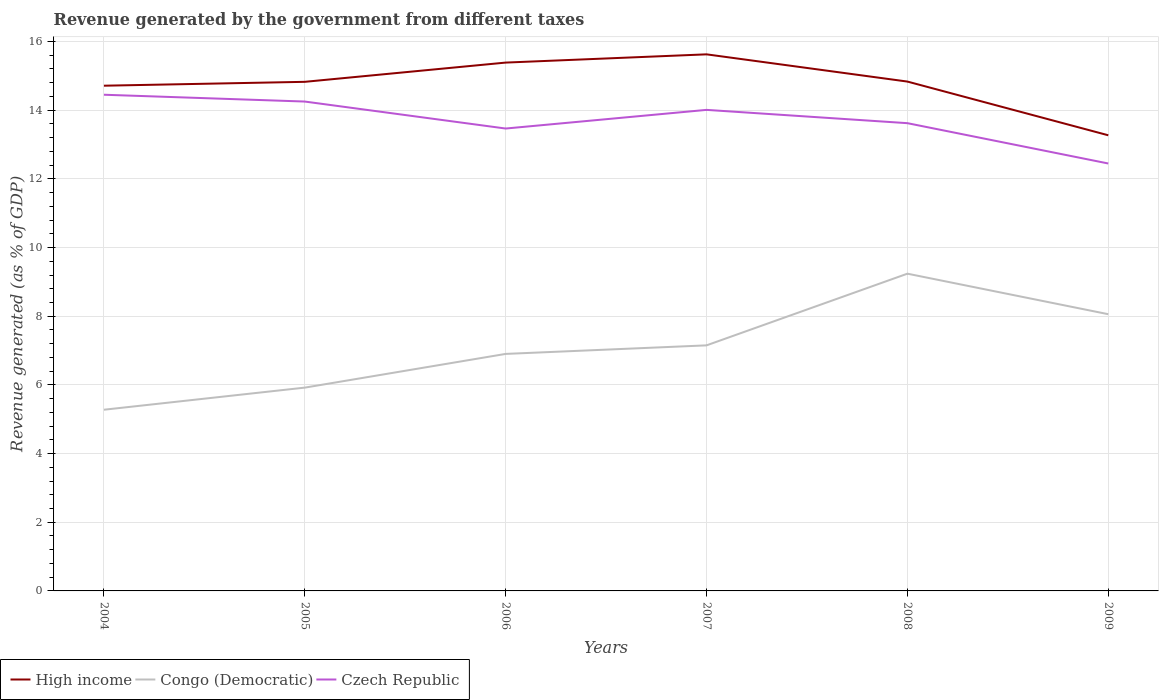Across all years, what is the maximum revenue generated by the government in Czech Republic?
Your answer should be compact. 12.45. What is the total revenue generated by the government in Czech Republic in the graph?
Your answer should be compact. 0.24. What is the difference between the highest and the second highest revenue generated by the government in High income?
Ensure brevity in your answer.  2.36. What is the difference between the highest and the lowest revenue generated by the government in Congo (Democratic)?
Offer a terse response. 3. How many lines are there?
Provide a succinct answer. 3. Are the values on the major ticks of Y-axis written in scientific E-notation?
Your response must be concise. No. What is the title of the graph?
Your answer should be compact. Revenue generated by the government from different taxes. What is the label or title of the Y-axis?
Make the answer very short. Revenue generated (as % of GDP). What is the Revenue generated (as % of GDP) in High income in 2004?
Offer a terse response. 14.71. What is the Revenue generated (as % of GDP) of Congo (Democratic) in 2004?
Make the answer very short. 5.28. What is the Revenue generated (as % of GDP) in Czech Republic in 2004?
Provide a short and direct response. 14.45. What is the Revenue generated (as % of GDP) of High income in 2005?
Your answer should be very brief. 14.83. What is the Revenue generated (as % of GDP) of Congo (Democratic) in 2005?
Provide a short and direct response. 5.92. What is the Revenue generated (as % of GDP) of Czech Republic in 2005?
Make the answer very short. 14.25. What is the Revenue generated (as % of GDP) in High income in 2006?
Give a very brief answer. 15.39. What is the Revenue generated (as % of GDP) in Congo (Democratic) in 2006?
Provide a short and direct response. 6.9. What is the Revenue generated (as % of GDP) of Czech Republic in 2006?
Provide a short and direct response. 13.47. What is the Revenue generated (as % of GDP) of High income in 2007?
Your response must be concise. 15.63. What is the Revenue generated (as % of GDP) in Congo (Democratic) in 2007?
Make the answer very short. 7.15. What is the Revenue generated (as % of GDP) in Czech Republic in 2007?
Your answer should be compact. 14.01. What is the Revenue generated (as % of GDP) of High income in 2008?
Make the answer very short. 14.83. What is the Revenue generated (as % of GDP) in Congo (Democratic) in 2008?
Give a very brief answer. 9.24. What is the Revenue generated (as % of GDP) of Czech Republic in 2008?
Make the answer very short. 13.62. What is the Revenue generated (as % of GDP) of High income in 2009?
Offer a very short reply. 13.27. What is the Revenue generated (as % of GDP) of Congo (Democratic) in 2009?
Make the answer very short. 8.06. What is the Revenue generated (as % of GDP) in Czech Republic in 2009?
Keep it short and to the point. 12.45. Across all years, what is the maximum Revenue generated (as % of GDP) of High income?
Make the answer very short. 15.63. Across all years, what is the maximum Revenue generated (as % of GDP) in Congo (Democratic)?
Offer a terse response. 9.24. Across all years, what is the maximum Revenue generated (as % of GDP) of Czech Republic?
Your answer should be very brief. 14.45. Across all years, what is the minimum Revenue generated (as % of GDP) of High income?
Offer a very short reply. 13.27. Across all years, what is the minimum Revenue generated (as % of GDP) in Congo (Democratic)?
Your answer should be compact. 5.28. Across all years, what is the minimum Revenue generated (as % of GDP) of Czech Republic?
Your answer should be compact. 12.45. What is the total Revenue generated (as % of GDP) of High income in the graph?
Give a very brief answer. 88.66. What is the total Revenue generated (as % of GDP) of Congo (Democratic) in the graph?
Your answer should be compact. 42.55. What is the total Revenue generated (as % of GDP) of Czech Republic in the graph?
Provide a succinct answer. 82.25. What is the difference between the Revenue generated (as % of GDP) in High income in 2004 and that in 2005?
Make the answer very short. -0.11. What is the difference between the Revenue generated (as % of GDP) of Congo (Democratic) in 2004 and that in 2005?
Your response must be concise. -0.64. What is the difference between the Revenue generated (as % of GDP) in Czech Republic in 2004 and that in 2005?
Offer a very short reply. 0.2. What is the difference between the Revenue generated (as % of GDP) of High income in 2004 and that in 2006?
Keep it short and to the point. -0.67. What is the difference between the Revenue generated (as % of GDP) in Congo (Democratic) in 2004 and that in 2006?
Offer a very short reply. -1.63. What is the difference between the Revenue generated (as % of GDP) in Czech Republic in 2004 and that in 2006?
Keep it short and to the point. 0.98. What is the difference between the Revenue generated (as % of GDP) in High income in 2004 and that in 2007?
Your response must be concise. -0.91. What is the difference between the Revenue generated (as % of GDP) of Congo (Democratic) in 2004 and that in 2007?
Provide a succinct answer. -1.87. What is the difference between the Revenue generated (as % of GDP) of Czech Republic in 2004 and that in 2007?
Provide a short and direct response. 0.44. What is the difference between the Revenue generated (as % of GDP) of High income in 2004 and that in 2008?
Your answer should be very brief. -0.12. What is the difference between the Revenue generated (as % of GDP) of Congo (Democratic) in 2004 and that in 2008?
Ensure brevity in your answer.  -3.96. What is the difference between the Revenue generated (as % of GDP) of Czech Republic in 2004 and that in 2008?
Keep it short and to the point. 0.83. What is the difference between the Revenue generated (as % of GDP) in High income in 2004 and that in 2009?
Provide a short and direct response. 1.44. What is the difference between the Revenue generated (as % of GDP) in Congo (Democratic) in 2004 and that in 2009?
Your answer should be compact. -2.78. What is the difference between the Revenue generated (as % of GDP) in Czech Republic in 2004 and that in 2009?
Provide a short and direct response. 2. What is the difference between the Revenue generated (as % of GDP) in High income in 2005 and that in 2006?
Make the answer very short. -0.56. What is the difference between the Revenue generated (as % of GDP) of Congo (Democratic) in 2005 and that in 2006?
Your answer should be compact. -0.98. What is the difference between the Revenue generated (as % of GDP) in Czech Republic in 2005 and that in 2006?
Ensure brevity in your answer.  0.79. What is the difference between the Revenue generated (as % of GDP) in High income in 2005 and that in 2007?
Make the answer very short. -0.8. What is the difference between the Revenue generated (as % of GDP) of Congo (Democratic) in 2005 and that in 2007?
Keep it short and to the point. -1.23. What is the difference between the Revenue generated (as % of GDP) in Czech Republic in 2005 and that in 2007?
Your answer should be compact. 0.24. What is the difference between the Revenue generated (as % of GDP) of High income in 2005 and that in 2008?
Your answer should be very brief. -0.01. What is the difference between the Revenue generated (as % of GDP) of Congo (Democratic) in 2005 and that in 2008?
Offer a very short reply. -3.32. What is the difference between the Revenue generated (as % of GDP) of Czech Republic in 2005 and that in 2008?
Ensure brevity in your answer.  0.63. What is the difference between the Revenue generated (as % of GDP) of High income in 2005 and that in 2009?
Offer a very short reply. 1.56. What is the difference between the Revenue generated (as % of GDP) in Congo (Democratic) in 2005 and that in 2009?
Keep it short and to the point. -2.14. What is the difference between the Revenue generated (as % of GDP) in Czech Republic in 2005 and that in 2009?
Your answer should be very brief. 1.8. What is the difference between the Revenue generated (as % of GDP) of High income in 2006 and that in 2007?
Offer a terse response. -0.24. What is the difference between the Revenue generated (as % of GDP) of Congo (Democratic) in 2006 and that in 2007?
Your response must be concise. -0.25. What is the difference between the Revenue generated (as % of GDP) of Czech Republic in 2006 and that in 2007?
Offer a terse response. -0.54. What is the difference between the Revenue generated (as % of GDP) of High income in 2006 and that in 2008?
Your response must be concise. 0.55. What is the difference between the Revenue generated (as % of GDP) of Congo (Democratic) in 2006 and that in 2008?
Ensure brevity in your answer.  -2.34. What is the difference between the Revenue generated (as % of GDP) of Czech Republic in 2006 and that in 2008?
Keep it short and to the point. -0.16. What is the difference between the Revenue generated (as % of GDP) of High income in 2006 and that in 2009?
Provide a succinct answer. 2.12. What is the difference between the Revenue generated (as % of GDP) in Congo (Democratic) in 2006 and that in 2009?
Ensure brevity in your answer.  -1.16. What is the difference between the Revenue generated (as % of GDP) of Czech Republic in 2006 and that in 2009?
Offer a terse response. 1.02. What is the difference between the Revenue generated (as % of GDP) in High income in 2007 and that in 2008?
Provide a short and direct response. 0.79. What is the difference between the Revenue generated (as % of GDP) in Congo (Democratic) in 2007 and that in 2008?
Provide a short and direct response. -2.09. What is the difference between the Revenue generated (as % of GDP) of Czech Republic in 2007 and that in 2008?
Your answer should be very brief. 0.39. What is the difference between the Revenue generated (as % of GDP) of High income in 2007 and that in 2009?
Your response must be concise. 2.36. What is the difference between the Revenue generated (as % of GDP) of Congo (Democratic) in 2007 and that in 2009?
Ensure brevity in your answer.  -0.91. What is the difference between the Revenue generated (as % of GDP) of Czech Republic in 2007 and that in 2009?
Ensure brevity in your answer.  1.56. What is the difference between the Revenue generated (as % of GDP) of High income in 2008 and that in 2009?
Provide a short and direct response. 1.56. What is the difference between the Revenue generated (as % of GDP) of Congo (Democratic) in 2008 and that in 2009?
Make the answer very short. 1.18. What is the difference between the Revenue generated (as % of GDP) in Czech Republic in 2008 and that in 2009?
Your answer should be very brief. 1.17. What is the difference between the Revenue generated (as % of GDP) in High income in 2004 and the Revenue generated (as % of GDP) in Congo (Democratic) in 2005?
Provide a short and direct response. 8.79. What is the difference between the Revenue generated (as % of GDP) of High income in 2004 and the Revenue generated (as % of GDP) of Czech Republic in 2005?
Provide a succinct answer. 0.46. What is the difference between the Revenue generated (as % of GDP) of Congo (Democratic) in 2004 and the Revenue generated (as % of GDP) of Czech Republic in 2005?
Give a very brief answer. -8.97. What is the difference between the Revenue generated (as % of GDP) of High income in 2004 and the Revenue generated (as % of GDP) of Congo (Democratic) in 2006?
Provide a short and direct response. 7.81. What is the difference between the Revenue generated (as % of GDP) of High income in 2004 and the Revenue generated (as % of GDP) of Czech Republic in 2006?
Your response must be concise. 1.25. What is the difference between the Revenue generated (as % of GDP) of Congo (Democratic) in 2004 and the Revenue generated (as % of GDP) of Czech Republic in 2006?
Your answer should be very brief. -8.19. What is the difference between the Revenue generated (as % of GDP) of High income in 2004 and the Revenue generated (as % of GDP) of Congo (Democratic) in 2007?
Make the answer very short. 7.56. What is the difference between the Revenue generated (as % of GDP) in High income in 2004 and the Revenue generated (as % of GDP) in Czech Republic in 2007?
Offer a very short reply. 0.7. What is the difference between the Revenue generated (as % of GDP) in Congo (Democratic) in 2004 and the Revenue generated (as % of GDP) in Czech Republic in 2007?
Make the answer very short. -8.73. What is the difference between the Revenue generated (as % of GDP) in High income in 2004 and the Revenue generated (as % of GDP) in Congo (Democratic) in 2008?
Ensure brevity in your answer.  5.47. What is the difference between the Revenue generated (as % of GDP) of High income in 2004 and the Revenue generated (as % of GDP) of Czech Republic in 2008?
Your answer should be compact. 1.09. What is the difference between the Revenue generated (as % of GDP) in Congo (Democratic) in 2004 and the Revenue generated (as % of GDP) in Czech Republic in 2008?
Your response must be concise. -8.35. What is the difference between the Revenue generated (as % of GDP) of High income in 2004 and the Revenue generated (as % of GDP) of Congo (Democratic) in 2009?
Give a very brief answer. 6.65. What is the difference between the Revenue generated (as % of GDP) in High income in 2004 and the Revenue generated (as % of GDP) in Czech Republic in 2009?
Offer a very short reply. 2.27. What is the difference between the Revenue generated (as % of GDP) of Congo (Democratic) in 2004 and the Revenue generated (as % of GDP) of Czech Republic in 2009?
Your answer should be very brief. -7.17. What is the difference between the Revenue generated (as % of GDP) in High income in 2005 and the Revenue generated (as % of GDP) in Congo (Democratic) in 2006?
Your answer should be very brief. 7.92. What is the difference between the Revenue generated (as % of GDP) in High income in 2005 and the Revenue generated (as % of GDP) in Czech Republic in 2006?
Offer a terse response. 1.36. What is the difference between the Revenue generated (as % of GDP) of Congo (Democratic) in 2005 and the Revenue generated (as % of GDP) of Czech Republic in 2006?
Your answer should be compact. -7.55. What is the difference between the Revenue generated (as % of GDP) in High income in 2005 and the Revenue generated (as % of GDP) in Congo (Democratic) in 2007?
Give a very brief answer. 7.67. What is the difference between the Revenue generated (as % of GDP) in High income in 2005 and the Revenue generated (as % of GDP) in Czech Republic in 2007?
Your response must be concise. 0.82. What is the difference between the Revenue generated (as % of GDP) of Congo (Democratic) in 2005 and the Revenue generated (as % of GDP) of Czech Republic in 2007?
Offer a terse response. -8.09. What is the difference between the Revenue generated (as % of GDP) in High income in 2005 and the Revenue generated (as % of GDP) in Congo (Democratic) in 2008?
Ensure brevity in your answer.  5.59. What is the difference between the Revenue generated (as % of GDP) in High income in 2005 and the Revenue generated (as % of GDP) in Czech Republic in 2008?
Offer a very short reply. 1.2. What is the difference between the Revenue generated (as % of GDP) of Congo (Democratic) in 2005 and the Revenue generated (as % of GDP) of Czech Republic in 2008?
Ensure brevity in your answer.  -7.7. What is the difference between the Revenue generated (as % of GDP) of High income in 2005 and the Revenue generated (as % of GDP) of Congo (Democratic) in 2009?
Ensure brevity in your answer.  6.77. What is the difference between the Revenue generated (as % of GDP) of High income in 2005 and the Revenue generated (as % of GDP) of Czech Republic in 2009?
Keep it short and to the point. 2.38. What is the difference between the Revenue generated (as % of GDP) of Congo (Democratic) in 2005 and the Revenue generated (as % of GDP) of Czech Republic in 2009?
Make the answer very short. -6.53. What is the difference between the Revenue generated (as % of GDP) of High income in 2006 and the Revenue generated (as % of GDP) of Congo (Democratic) in 2007?
Offer a very short reply. 8.23. What is the difference between the Revenue generated (as % of GDP) of High income in 2006 and the Revenue generated (as % of GDP) of Czech Republic in 2007?
Your response must be concise. 1.38. What is the difference between the Revenue generated (as % of GDP) of Congo (Democratic) in 2006 and the Revenue generated (as % of GDP) of Czech Republic in 2007?
Make the answer very short. -7.11. What is the difference between the Revenue generated (as % of GDP) in High income in 2006 and the Revenue generated (as % of GDP) in Congo (Democratic) in 2008?
Make the answer very short. 6.15. What is the difference between the Revenue generated (as % of GDP) of High income in 2006 and the Revenue generated (as % of GDP) of Czech Republic in 2008?
Your answer should be compact. 1.76. What is the difference between the Revenue generated (as % of GDP) in Congo (Democratic) in 2006 and the Revenue generated (as % of GDP) in Czech Republic in 2008?
Your response must be concise. -6.72. What is the difference between the Revenue generated (as % of GDP) in High income in 2006 and the Revenue generated (as % of GDP) in Congo (Democratic) in 2009?
Offer a very short reply. 7.33. What is the difference between the Revenue generated (as % of GDP) of High income in 2006 and the Revenue generated (as % of GDP) of Czech Republic in 2009?
Give a very brief answer. 2.94. What is the difference between the Revenue generated (as % of GDP) of Congo (Democratic) in 2006 and the Revenue generated (as % of GDP) of Czech Republic in 2009?
Keep it short and to the point. -5.55. What is the difference between the Revenue generated (as % of GDP) in High income in 2007 and the Revenue generated (as % of GDP) in Congo (Democratic) in 2008?
Your answer should be compact. 6.39. What is the difference between the Revenue generated (as % of GDP) in High income in 2007 and the Revenue generated (as % of GDP) in Czech Republic in 2008?
Your answer should be very brief. 2. What is the difference between the Revenue generated (as % of GDP) of Congo (Democratic) in 2007 and the Revenue generated (as % of GDP) of Czech Republic in 2008?
Provide a short and direct response. -6.47. What is the difference between the Revenue generated (as % of GDP) in High income in 2007 and the Revenue generated (as % of GDP) in Congo (Democratic) in 2009?
Your answer should be compact. 7.57. What is the difference between the Revenue generated (as % of GDP) of High income in 2007 and the Revenue generated (as % of GDP) of Czech Republic in 2009?
Your answer should be compact. 3.18. What is the difference between the Revenue generated (as % of GDP) of Congo (Democratic) in 2007 and the Revenue generated (as % of GDP) of Czech Republic in 2009?
Provide a succinct answer. -5.3. What is the difference between the Revenue generated (as % of GDP) of High income in 2008 and the Revenue generated (as % of GDP) of Congo (Democratic) in 2009?
Ensure brevity in your answer.  6.77. What is the difference between the Revenue generated (as % of GDP) in High income in 2008 and the Revenue generated (as % of GDP) in Czech Republic in 2009?
Ensure brevity in your answer.  2.39. What is the difference between the Revenue generated (as % of GDP) of Congo (Democratic) in 2008 and the Revenue generated (as % of GDP) of Czech Republic in 2009?
Your answer should be very brief. -3.21. What is the average Revenue generated (as % of GDP) in High income per year?
Provide a succinct answer. 14.78. What is the average Revenue generated (as % of GDP) of Congo (Democratic) per year?
Offer a very short reply. 7.09. What is the average Revenue generated (as % of GDP) in Czech Republic per year?
Your answer should be compact. 13.71. In the year 2004, what is the difference between the Revenue generated (as % of GDP) of High income and Revenue generated (as % of GDP) of Congo (Democratic)?
Give a very brief answer. 9.44. In the year 2004, what is the difference between the Revenue generated (as % of GDP) in High income and Revenue generated (as % of GDP) in Czech Republic?
Offer a very short reply. 0.26. In the year 2004, what is the difference between the Revenue generated (as % of GDP) in Congo (Democratic) and Revenue generated (as % of GDP) in Czech Republic?
Your response must be concise. -9.17. In the year 2005, what is the difference between the Revenue generated (as % of GDP) of High income and Revenue generated (as % of GDP) of Congo (Democratic)?
Your answer should be very brief. 8.91. In the year 2005, what is the difference between the Revenue generated (as % of GDP) of High income and Revenue generated (as % of GDP) of Czech Republic?
Ensure brevity in your answer.  0.57. In the year 2005, what is the difference between the Revenue generated (as % of GDP) of Congo (Democratic) and Revenue generated (as % of GDP) of Czech Republic?
Provide a succinct answer. -8.33. In the year 2006, what is the difference between the Revenue generated (as % of GDP) in High income and Revenue generated (as % of GDP) in Congo (Democratic)?
Give a very brief answer. 8.48. In the year 2006, what is the difference between the Revenue generated (as % of GDP) of High income and Revenue generated (as % of GDP) of Czech Republic?
Give a very brief answer. 1.92. In the year 2006, what is the difference between the Revenue generated (as % of GDP) of Congo (Democratic) and Revenue generated (as % of GDP) of Czech Republic?
Provide a short and direct response. -6.56. In the year 2007, what is the difference between the Revenue generated (as % of GDP) in High income and Revenue generated (as % of GDP) in Congo (Democratic)?
Keep it short and to the point. 8.47. In the year 2007, what is the difference between the Revenue generated (as % of GDP) in High income and Revenue generated (as % of GDP) in Czech Republic?
Ensure brevity in your answer.  1.62. In the year 2007, what is the difference between the Revenue generated (as % of GDP) of Congo (Democratic) and Revenue generated (as % of GDP) of Czech Republic?
Your answer should be very brief. -6.86. In the year 2008, what is the difference between the Revenue generated (as % of GDP) of High income and Revenue generated (as % of GDP) of Congo (Democratic)?
Your response must be concise. 5.59. In the year 2008, what is the difference between the Revenue generated (as % of GDP) of High income and Revenue generated (as % of GDP) of Czech Republic?
Provide a short and direct response. 1.21. In the year 2008, what is the difference between the Revenue generated (as % of GDP) in Congo (Democratic) and Revenue generated (as % of GDP) in Czech Republic?
Your response must be concise. -4.38. In the year 2009, what is the difference between the Revenue generated (as % of GDP) of High income and Revenue generated (as % of GDP) of Congo (Democratic)?
Keep it short and to the point. 5.21. In the year 2009, what is the difference between the Revenue generated (as % of GDP) of High income and Revenue generated (as % of GDP) of Czech Republic?
Offer a terse response. 0.82. In the year 2009, what is the difference between the Revenue generated (as % of GDP) in Congo (Democratic) and Revenue generated (as % of GDP) in Czech Republic?
Your answer should be compact. -4.39. What is the ratio of the Revenue generated (as % of GDP) of Congo (Democratic) in 2004 to that in 2005?
Ensure brevity in your answer.  0.89. What is the ratio of the Revenue generated (as % of GDP) in Czech Republic in 2004 to that in 2005?
Your answer should be very brief. 1.01. What is the ratio of the Revenue generated (as % of GDP) of High income in 2004 to that in 2006?
Offer a terse response. 0.96. What is the ratio of the Revenue generated (as % of GDP) of Congo (Democratic) in 2004 to that in 2006?
Provide a short and direct response. 0.76. What is the ratio of the Revenue generated (as % of GDP) of Czech Republic in 2004 to that in 2006?
Make the answer very short. 1.07. What is the ratio of the Revenue generated (as % of GDP) in High income in 2004 to that in 2007?
Provide a short and direct response. 0.94. What is the ratio of the Revenue generated (as % of GDP) in Congo (Democratic) in 2004 to that in 2007?
Your answer should be compact. 0.74. What is the ratio of the Revenue generated (as % of GDP) of Czech Republic in 2004 to that in 2007?
Provide a succinct answer. 1.03. What is the ratio of the Revenue generated (as % of GDP) of High income in 2004 to that in 2008?
Offer a very short reply. 0.99. What is the ratio of the Revenue generated (as % of GDP) of Congo (Democratic) in 2004 to that in 2008?
Offer a very short reply. 0.57. What is the ratio of the Revenue generated (as % of GDP) in Czech Republic in 2004 to that in 2008?
Keep it short and to the point. 1.06. What is the ratio of the Revenue generated (as % of GDP) of High income in 2004 to that in 2009?
Offer a terse response. 1.11. What is the ratio of the Revenue generated (as % of GDP) of Congo (Democratic) in 2004 to that in 2009?
Provide a succinct answer. 0.65. What is the ratio of the Revenue generated (as % of GDP) of Czech Republic in 2004 to that in 2009?
Ensure brevity in your answer.  1.16. What is the ratio of the Revenue generated (as % of GDP) in High income in 2005 to that in 2006?
Ensure brevity in your answer.  0.96. What is the ratio of the Revenue generated (as % of GDP) of Congo (Democratic) in 2005 to that in 2006?
Offer a very short reply. 0.86. What is the ratio of the Revenue generated (as % of GDP) in Czech Republic in 2005 to that in 2006?
Provide a succinct answer. 1.06. What is the ratio of the Revenue generated (as % of GDP) of High income in 2005 to that in 2007?
Offer a terse response. 0.95. What is the ratio of the Revenue generated (as % of GDP) of Congo (Democratic) in 2005 to that in 2007?
Keep it short and to the point. 0.83. What is the ratio of the Revenue generated (as % of GDP) in Czech Republic in 2005 to that in 2007?
Your answer should be compact. 1.02. What is the ratio of the Revenue generated (as % of GDP) of High income in 2005 to that in 2008?
Provide a short and direct response. 1. What is the ratio of the Revenue generated (as % of GDP) of Congo (Democratic) in 2005 to that in 2008?
Keep it short and to the point. 0.64. What is the ratio of the Revenue generated (as % of GDP) in Czech Republic in 2005 to that in 2008?
Give a very brief answer. 1.05. What is the ratio of the Revenue generated (as % of GDP) of High income in 2005 to that in 2009?
Ensure brevity in your answer.  1.12. What is the ratio of the Revenue generated (as % of GDP) in Congo (Democratic) in 2005 to that in 2009?
Give a very brief answer. 0.73. What is the ratio of the Revenue generated (as % of GDP) in Czech Republic in 2005 to that in 2009?
Provide a short and direct response. 1.14. What is the ratio of the Revenue generated (as % of GDP) in High income in 2006 to that in 2007?
Your answer should be compact. 0.98. What is the ratio of the Revenue generated (as % of GDP) of Congo (Democratic) in 2006 to that in 2007?
Ensure brevity in your answer.  0.97. What is the ratio of the Revenue generated (as % of GDP) of Czech Republic in 2006 to that in 2007?
Your answer should be compact. 0.96. What is the ratio of the Revenue generated (as % of GDP) in High income in 2006 to that in 2008?
Provide a succinct answer. 1.04. What is the ratio of the Revenue generated (as % of GDP) in Congo (Democratic) in 2006 to that in 2008?
Provide a succinct answer. 0.75. What is the ratio of the Revenue generated (as % of GDP) of High income in 2006 to that in 2009?
Your answer should be very brief. 1.16. What is the ratio of the Revenue generated (as % of GDP) in Congo (Democratic) in 2006 to that in 2009?
Offer a terse response. 0.86. What is the ratio of the Revenue generated (as % of GDP) in Czech Republic in 2006 to that in 2009?
Offer a terse response. 1.08. What is the ratio of the Revenue generated (as % of GDP) of High income in 2007 to that in 2008?
Your answer should be very brief. 1.05. What is the ratio of the Revenue generated (as % of GDP) of Congo (Democratic) in 2007 to that in 2008?
Provide a short and direct response. 0.77. What is the ratio of the Revenue generated (as % of GDP) in Czech Republic in 2007 to that in 2008?
Offer a very short reply. 1.03. What is the ratio of the Revenue generated (as % of GDP) of High income in 2007 to that in 2009?
Give a very brief answer. 1.18. What is the ratio of the Revenue generated (as % of GDP) of Congo (Democratic) in 2007 to that in 2009?
Keep it short and to the point. 0.89. What is the ratio of the Revenue generated (as % of GDP) in Czech Republic in 2007 to that in 2009?
Ensure brevity in your answer.  1.13. What is the ratio of the Revenue generated (as % of GDP) of High income in 2008 to that in 2009?
Offer a terse response. 1.12. What is the ratio of the Revenue generated (as % of GDP) in Congo (Democratic) in 2008 to that in 2009?
Provide a succinct answer. 1.15. What is the ratio of the Revenue generated (as % of GDP) in Czech Republic in 2008 to that in 2009?
Provide a succinct answer. 1.09. What is the difference between the highest and the second highest Revenue generated (as % of GDP) in High income?
Keep it short and to the point. 0.24. What is the difference between the highest and the second highest Revenue generated (as % of GDP) of Congo (Democratic)?
Keep it short and to the point. 1.18. What is the difference between the highest and the second highest Revenue generated (as % of GDP) in Czech Republic?
Ensure brevity in your answer.  0.2. What is the difference between the highest and the lowest Revenue generated (as % of GDP) of High income?
Offer a terse response. 2.36. What is the difference between the highest and the lowest Revenue generated (as % of GDP) of Congo (Democratic)?
Ensure brevity in your answer.  3.96. What is the difference between the highest and the lowest Revenue generated (as % of GDP) of Czech Republic?
Offer a very short reply. 2. 